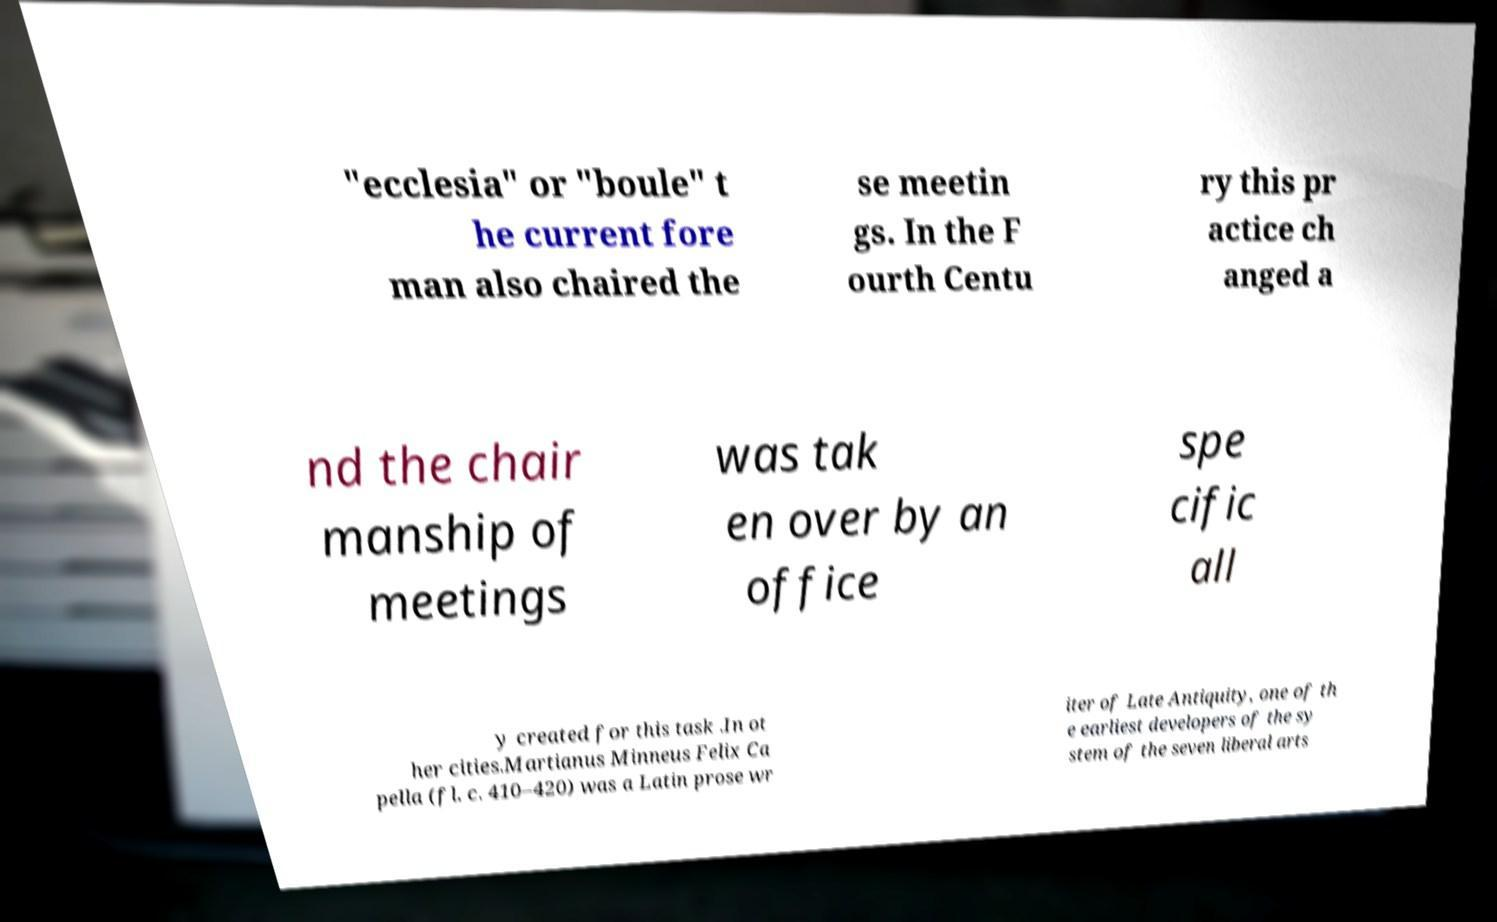Please identify and transcribe the text found in this image. "ecclesia" or "boule" t he current fore man also chaired the se meetin gs. In the F ourth Centu ry this pr actice ch anged a nd the chair manship of meetings was tak en over by an office spe cific all y created for this task .In ot her cities.Martianus Minneus Felix Ca pella (fl. c. 410–420) was a Latin prose wr iter of Late Antiquity, one of th e earliest developers of the sy stem of the seven liberal arts 